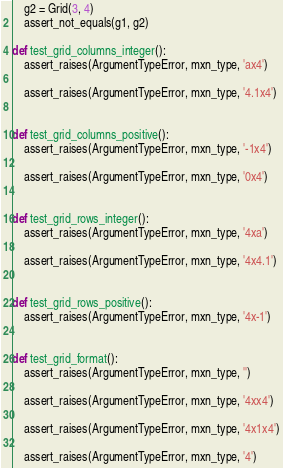<code> <loc_0><loc_0><loc_500><loc_500><_Python_>    g2 = Grid(3, 4)
    assert_not_equals(g1, g2)

def test_grid_columns_integer():
    assert_raises(ArgumentTypeError, mxn_type, 'ax4')

    assert_raises(ArgumentTypeError, mxn_type, '4.1x4')


def test_grid_columns_positive():
    assert_raises(ArgumentTypeError, mxn_type, '-1x4')

    assert_raises(ArgumentTypeError, mxn_type, '0x4')


def test_grid_rows_integer():
    assert_raises(ArgumentTypeError, mxn_type, '4xa')

    assert_raises(ArgumentTypeError, mxn_type, '4x4.1')


def test_grid_rows_positive():
    assert_raises(ArgumentTypeError, mxn_type, '4x-1')


def test_grid_format():
    assert_raises(ArgumentTypeError, mxn_type, '')

    assert_raises(ArgumentTypeError, mxn_type, '4xx4')

    assert_raises(ArgumentTypeError, mxn_type, '4x1x4')

    assert_raises(ArgumentTypeError, mxn_type, '4')
</code> 